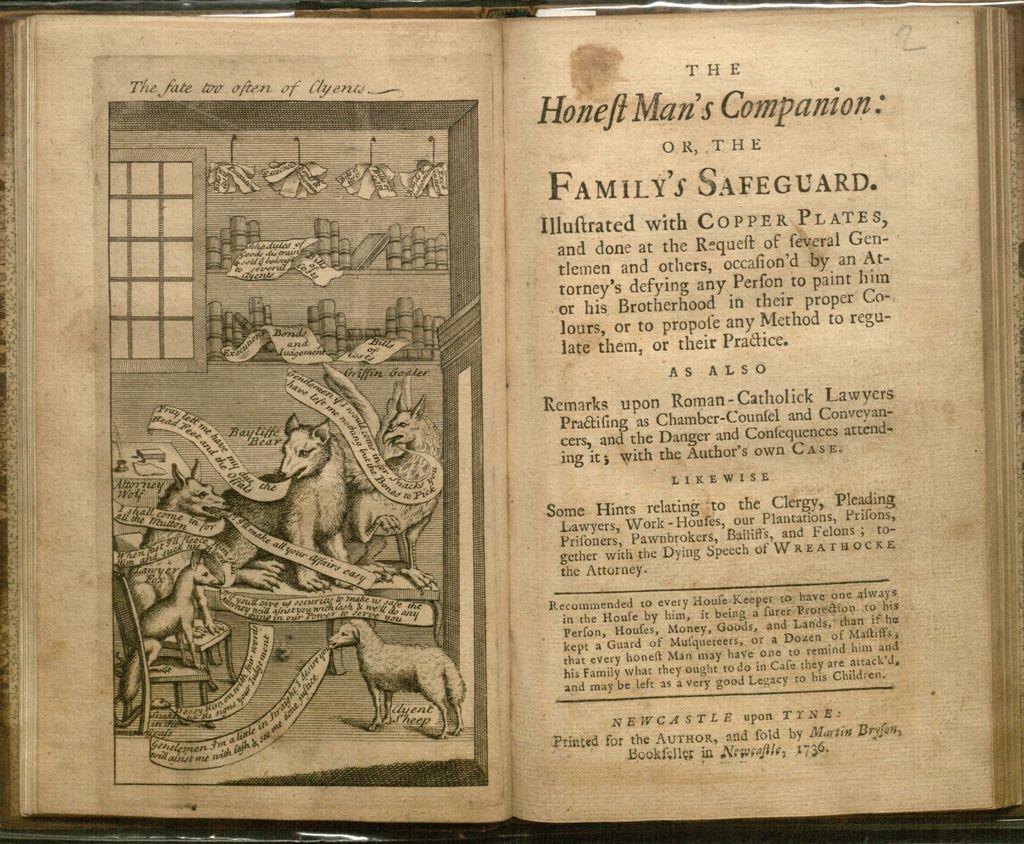What is the title of the page on the right?
Provide a succinct answer. Honeft man's companion. 